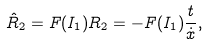Convert formula to latex. <formula><loc_0><loc_0><loc_500><loc_500>\hat { R } _ { 2 } & = F ( I _ { 1 } ) R _ { 2 } = - F ( I _ { 1 } ) \frac { t } { \dot { x } } ,</formula> 